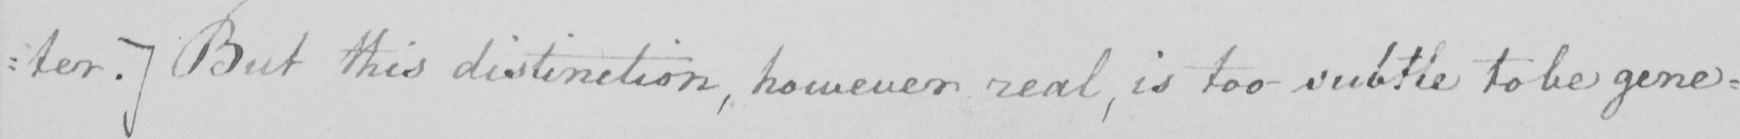What does this handwritten line say? : ter . ]  But this distinction  , however real , is too subtle to be gene : 